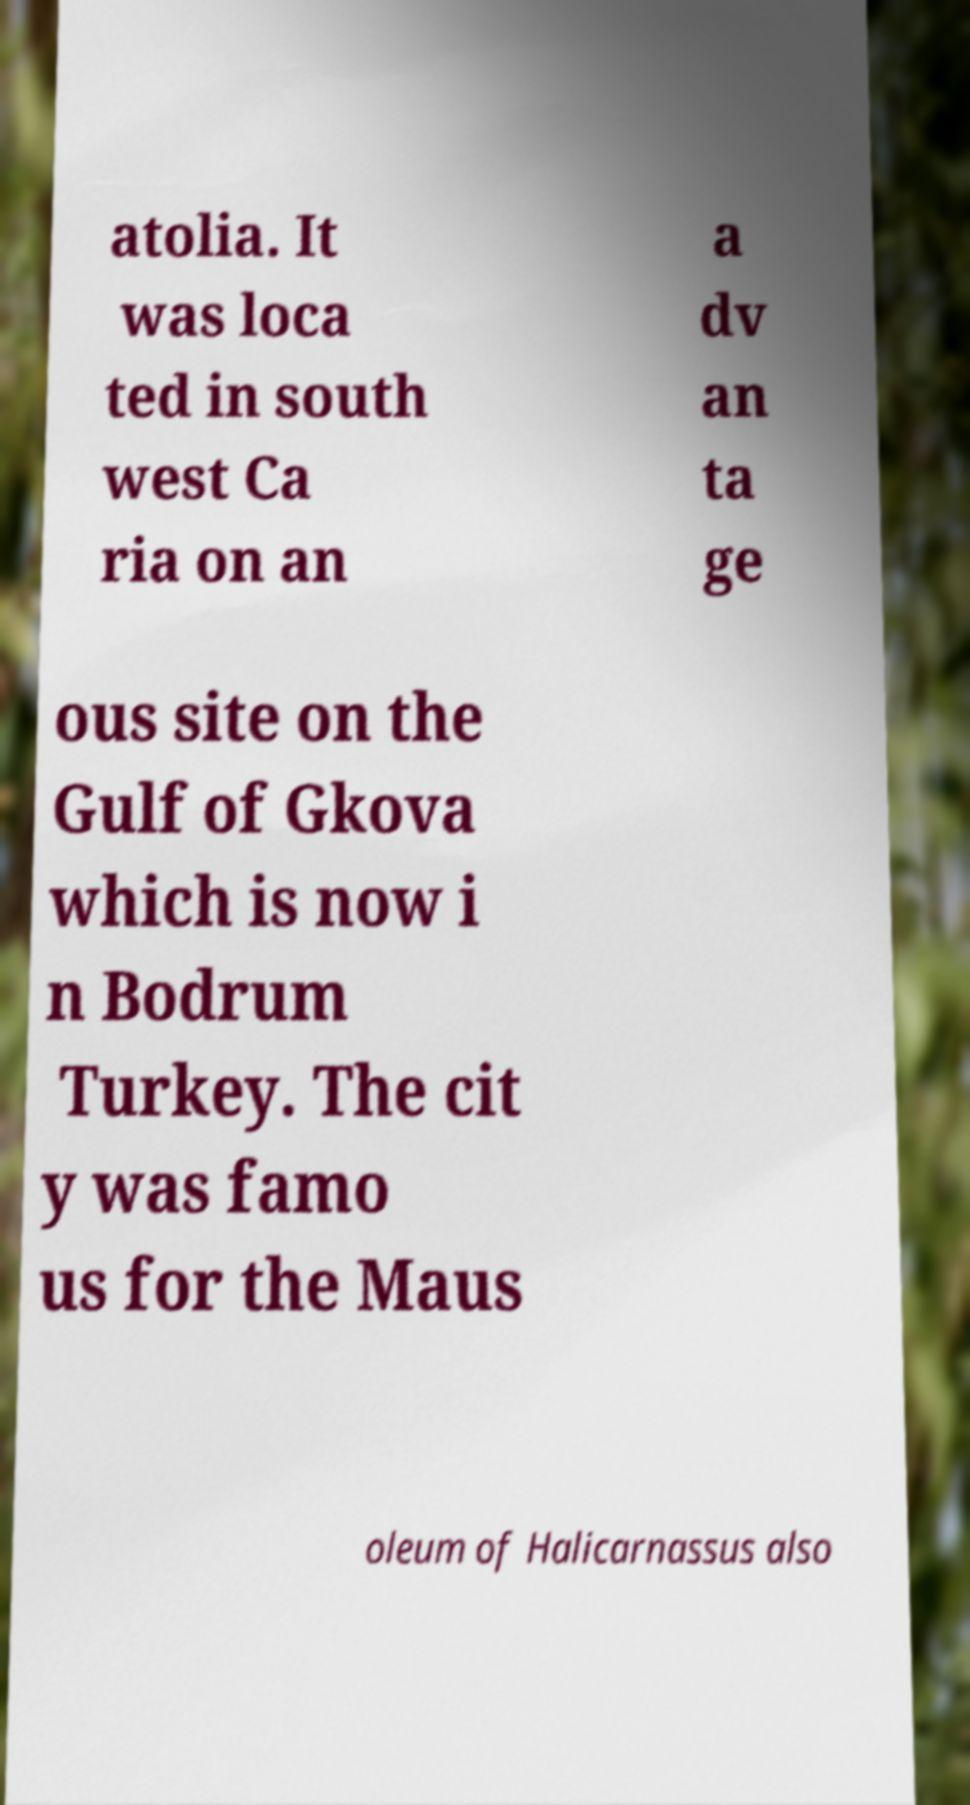I need the written content from this picture converted into text. Can you do that? atolia. It was loca ted in south west Ca ria on an a dv an ta ge ous site on the Gulf of Gkova which is now i n Bodrum Turkey. The cit y was famo us for the Maus oleum of Halicarnassus also 